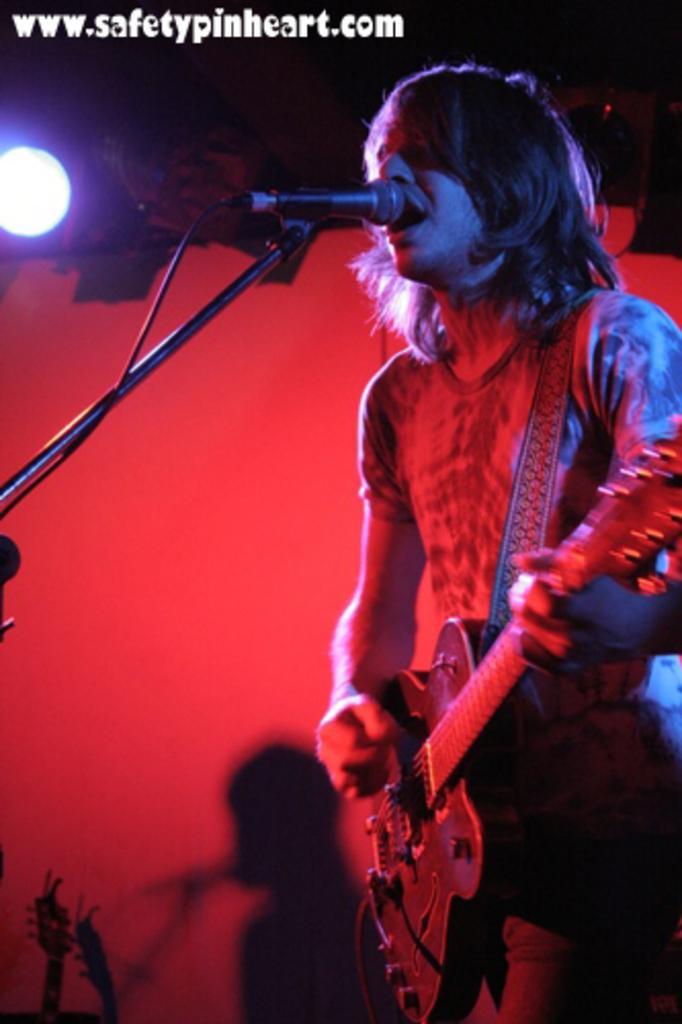Could you give a brief overview of what you see in this image? In this picture there is a man holding a guitar and singing. There is a mic and light at the background. 